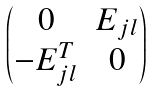Convert formula to latex. <formula><loc_0><loc_0><loc_500><loc_500>\begin{pmatrix} 0 & E _ { j l } \\ - E _ { j l } ^ { T } & 0 \end{pmatrix}</formula> 